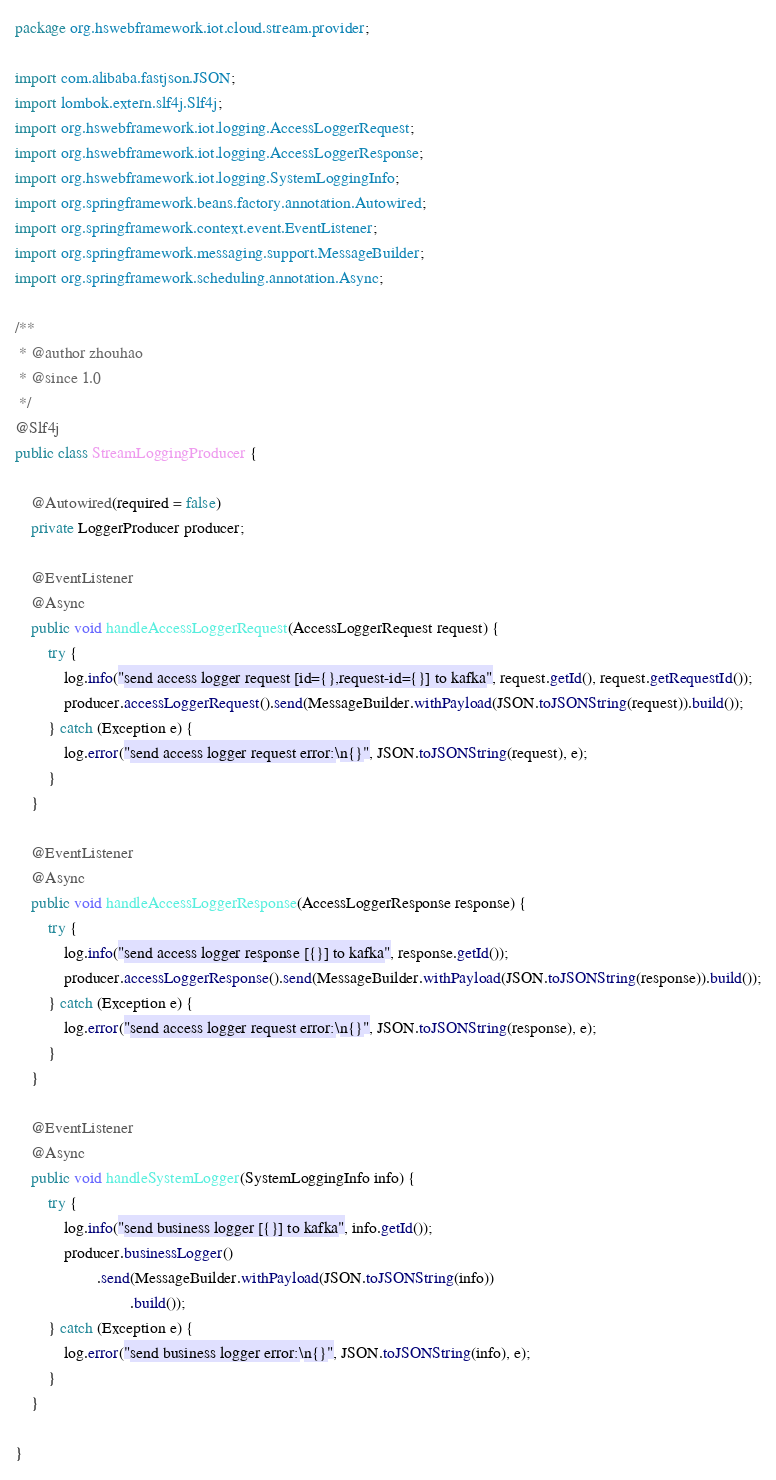Convert code to text. <code><loc_0><loc_0><loc_500><loc_500><_Java_>package org.hswebframework.iot.cloud.stream.provider;

import com.alibaba.fastjson.JSON;
import lombok.extern.slf4j.Slf4j;
import org.hswebframework.iot.logging.AccessLoggerRequest;
import org.hswebframework.iot.logging.AccessLoggerResponse;
import org.hswebframework.iot.logging.SystemLoggingInfo;
import org.springframework.beans.factory.annotation.Autowired;
import org.springframework.context.event.EventListener;
import org.springframework.messaging.support.MessageBuilder;
import org.springframework.scheduling.annotation.Async;

/**
 * @author zhouhao
 * @since 1.0
 */
@Slf4j
public class StreamLoggingProducer {

    @Autowired(required = false)
    private LoggerProducer producer;

    @EventListener
    @Async
    public void handleAccessLoggerRequest(AccessLoggerRequest request) {
        try {
            log.info("send access logger request [id={},request-id={}] to kafka", request.getId(), request.getRequestId());
            producer.accessLoggerRequest().send(MessageBuilder.withPayload(JSON.toJSONString(request)).build());
        } catch (Exception e) {
            log.error("send access logger request error:\n{}", JSON.toJSONString(request), e);
        }
    }

    @EventListener
    @Async
    public void handleAccessLoggerResponse(AccessLoggerResponse response) {
        try {
            log.info("send access logger response [{}] to kafka", response.getId());
            producer.accessLoggerResponse().send(MessageBuilder.withPayload(JSON.toJSONString(response)).build());
        } catch (Exception e) {
            log.error("send access logger request error:\n{}", JSON.toJSONString(response), e);
        }
    }

    @EventListener
    @Async
    public void handleSystemLogger(SystemLoggingInfo info) {
        try {
            log.info("send business logger [{}] to kafka", info.getId());
            producer.businessLogger()
                    .send(MessageBuilder.withPayload(JSON.toJSONString(info))
                            .build());
        } catch (Exception e) {
            log.error("send business logger error:\n{}", JSON.toJSONString(info), e);
        }
    }

}
</code> 